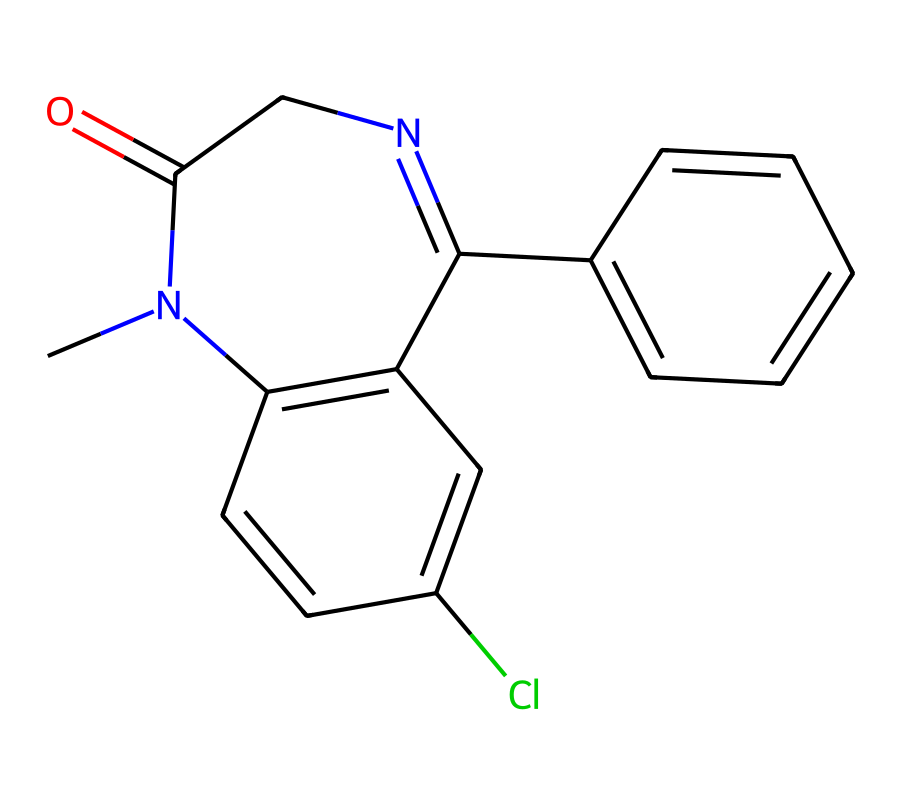What is the molecular formula of diazepam? To determine the molecular formula from the SMILES representation, we count the atoms of each element present. The SMILES indicates there are 16 carbon atoms (C), 14 hydrogen atoms (H), 1 chlorine atom (Cl), 3 nitrogen atoms (N), and 1 oxygen atom (O). Therefore, the molecular formula is C16H14ClN3O.
Answer: C16H14ClN3O How many nitrogen atoms are in diazepam? From the SMILES representation, we can identify the presence of nitrogen (N) atoms. By carefully analyzing the structure, we see there are three nitrogen atoms in total.
Answer: 3 Is diazepam structurally related to other benzodiazepines? Diazepam is a type of benzodiazepine, which is characterized by a benzene ring fused to a diazepine. The presence of such fused rings, specifically the two connected nitrogen atoms, indicates its classification within the benzodiazepine family.
Answer: Yes What functional groups are present in diazepam? By examining the structure, we identify functional groups such as the carbonyl group (C=O) indicated by the presence of a ketone, and the presence of the aromatic ring system signifies it contains an aromatic functional group. Thus, it contains a carbonyl and aromatic groups.
Answer: Carbonyl, aromatic Do carbenes participate in diazepam's formation? Carbenes are reactive intermediates and are not directly involved in the structure or formation of diazepam, which is synthesized through different organic reactions. Hence, they do not play a role in its chemical constitution or activity.
Answer: No 